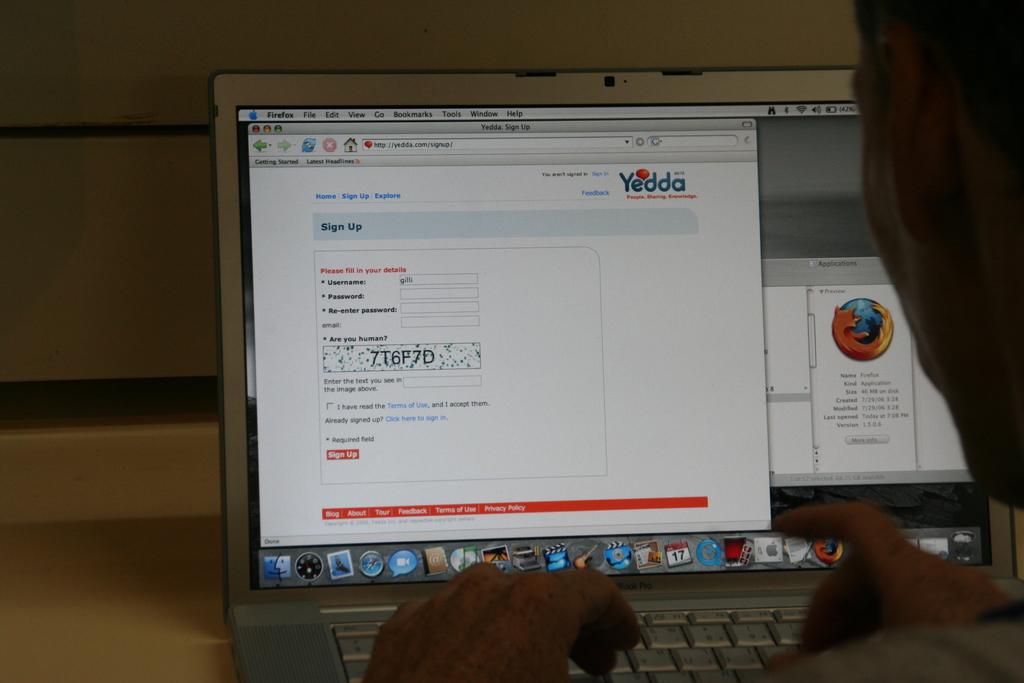Is this laptop using firefox?
Provide a succinct answer. Yes. 